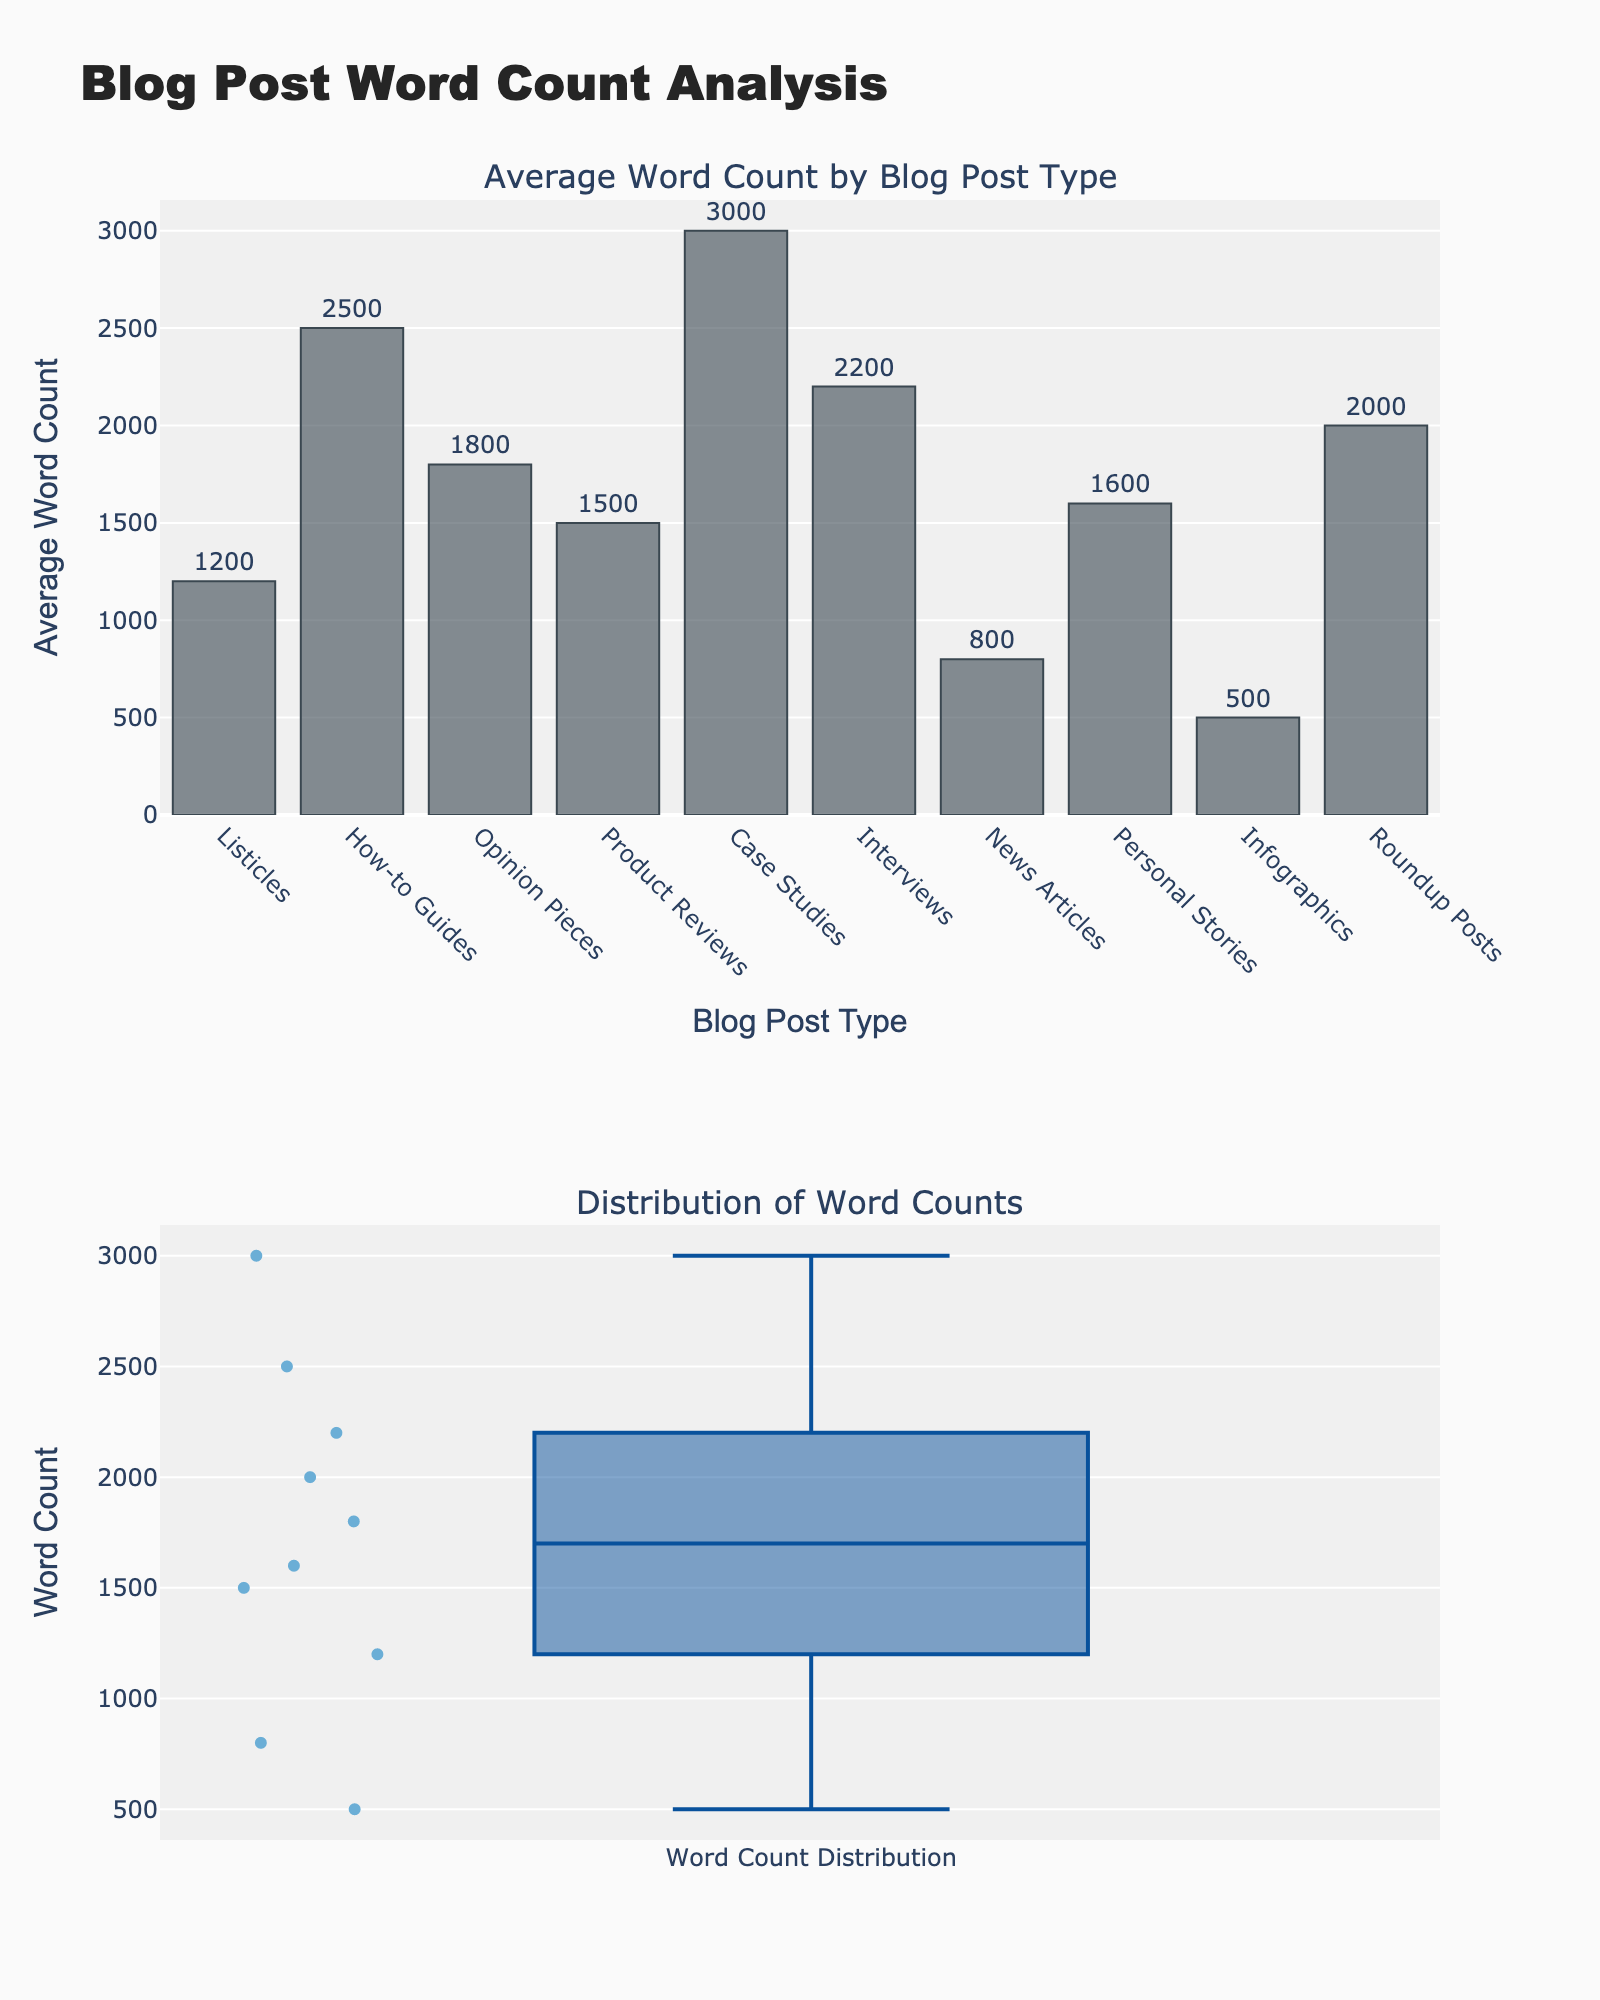What is the title of the overall plot? The title is located at the top of the figure and reads "Blog Post Word Count Analysis."
Answer: Blog Post Word Count Analysis What type of blog posts has the highest average word count? By looking at the heights of bars in the bar chart, the tallest bar represents "Case Studies" with an average word count of 3000.
Answer: Case Studies Which blog post type has the shortest average word count? The shortest bar in the bar chart indicates "Infographics" with an average word count of 500.
Answer: Infographics What is the average word count of How-to Guides? The bar labeled "How-to Guides" displays the text "2500" above it, indicating its average word count.
Answer: 2500 How many blog post types have an average word count exceeding 2000? By inspecting the bar chart, there are three blog post types with bars exceeding the 2000 mark: How-to Guides, Case Studies, and Interviews.
Answer: 3 Which blog post type has a higher average word count: News Articles or Product Reviews? Comparing the heights of the bars, News Articles has an average of 800, while Product Reviews has 1500. Therefore, Product Reviews have a higher average.
Answer: Product Reviews Is the average word count of Listicles greater than the word count of Personal Stories? By comparing the bars for both types, Listicles have 1200 and Personal Stories have 1600. Hence, Personal Stories have a higher average.
Answer: No What is the range of the blog post types' average word counts? The range can be found by subtracting the smallest value (Infographics, 500) from the largest value (Case Studies, 3000). So, 3000 - 500 = 2500.
Answer: 2500 Which blog post types fall within the middle 50% or interquartile range (IQR) of the word counts displayed in the box plot? The box plot displays a range, and the middle 50% (IQR) includes values roughly between 1200 and 2200. Blog post types in this range include Listicles, Opinion Pieces, Product Reviews, and Personal Stories.
Answer: Listicles, Opinion Pieces, Product Reviews, Personal Stories 